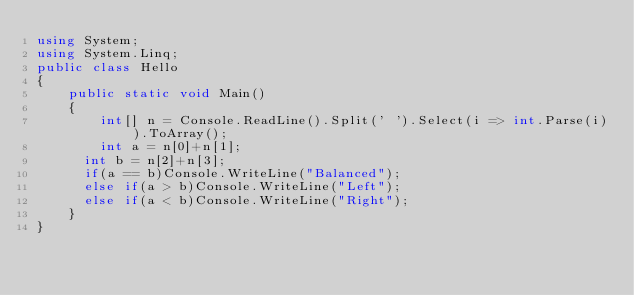Convert code to text. <code><loc_0><loc_0><loc_500><loc_500><_C#_>using System;
using System.Linq;
public class Hello
{
    public static void Main()
    {
        int[] n = Console.ReadLine().Split(' ').Select(i => int.Parse(i)).ToArray();
        int a = n[0]+n[1];
      int b = n[2]+n[3];
      if(a == b)Console.WriteLine("Balanced");
      else if(a > b)Console.WriteLine("Left");
      else if(a < b)Console.WriteLine("Right");
    }
}</code> 